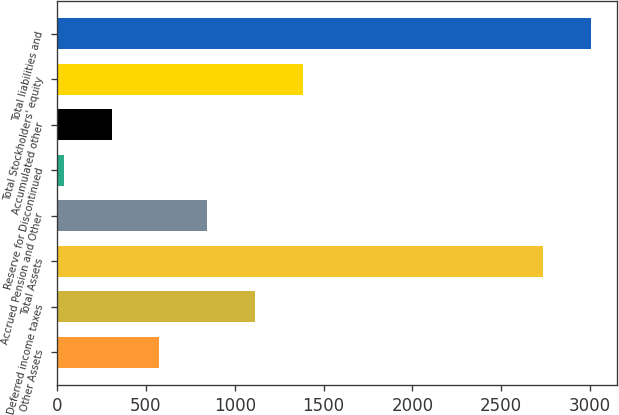Convert chart. <chart><loc_0><loc_0><loc_500><loc_500><bar_chart><fcel>Other Assets<fcel>Deferred income taxes<fcel>Total Assets<fcel>Accrued Pension and Other<fcel>Reserve for Discontinued<fcel>Accumulated other<fcel>Total Stockholders' equity<fcel>Total liabilities and<nl><fcel>576.04<fcel>1115.78<fcel>2735<fcel>845.91<fcel>36.3<fcel>306.17<fcel>1385.65<fcel>3004.87<nl></chart> 